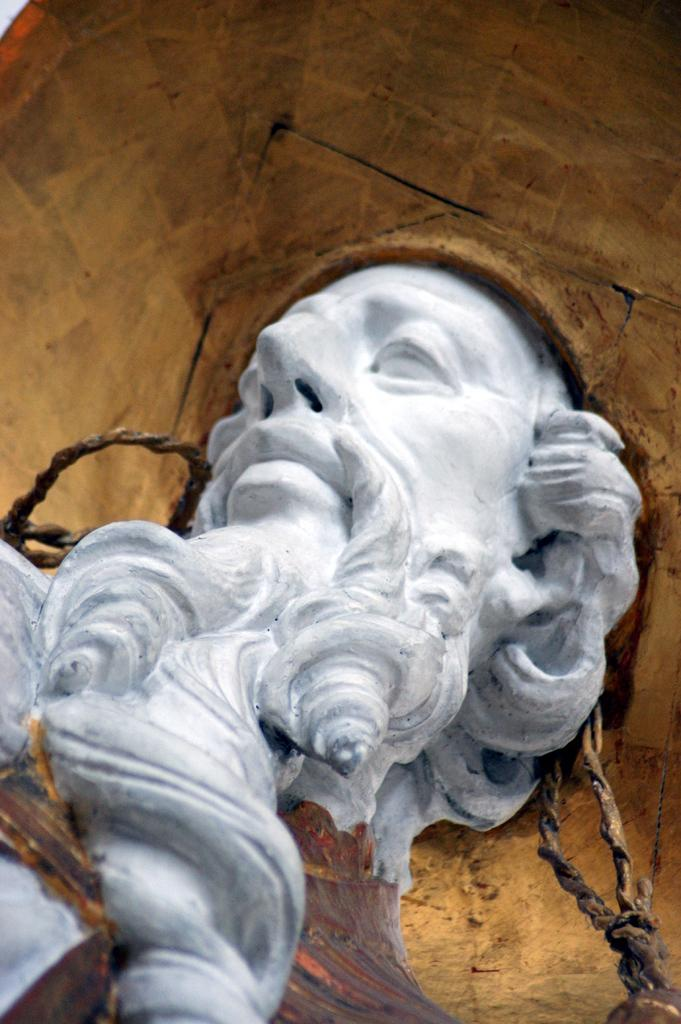What is the main subject in the center of the image? There is a sculpture in the center of the image. What can be seen in the background of the image? There is a wall in the background of the image. How many girls are present in the image? There is no mention of girls in the image, as it features a sculpture and a wall. What country is the sculpture from? The country of origin for the sculpture is not mentioned in the image. 